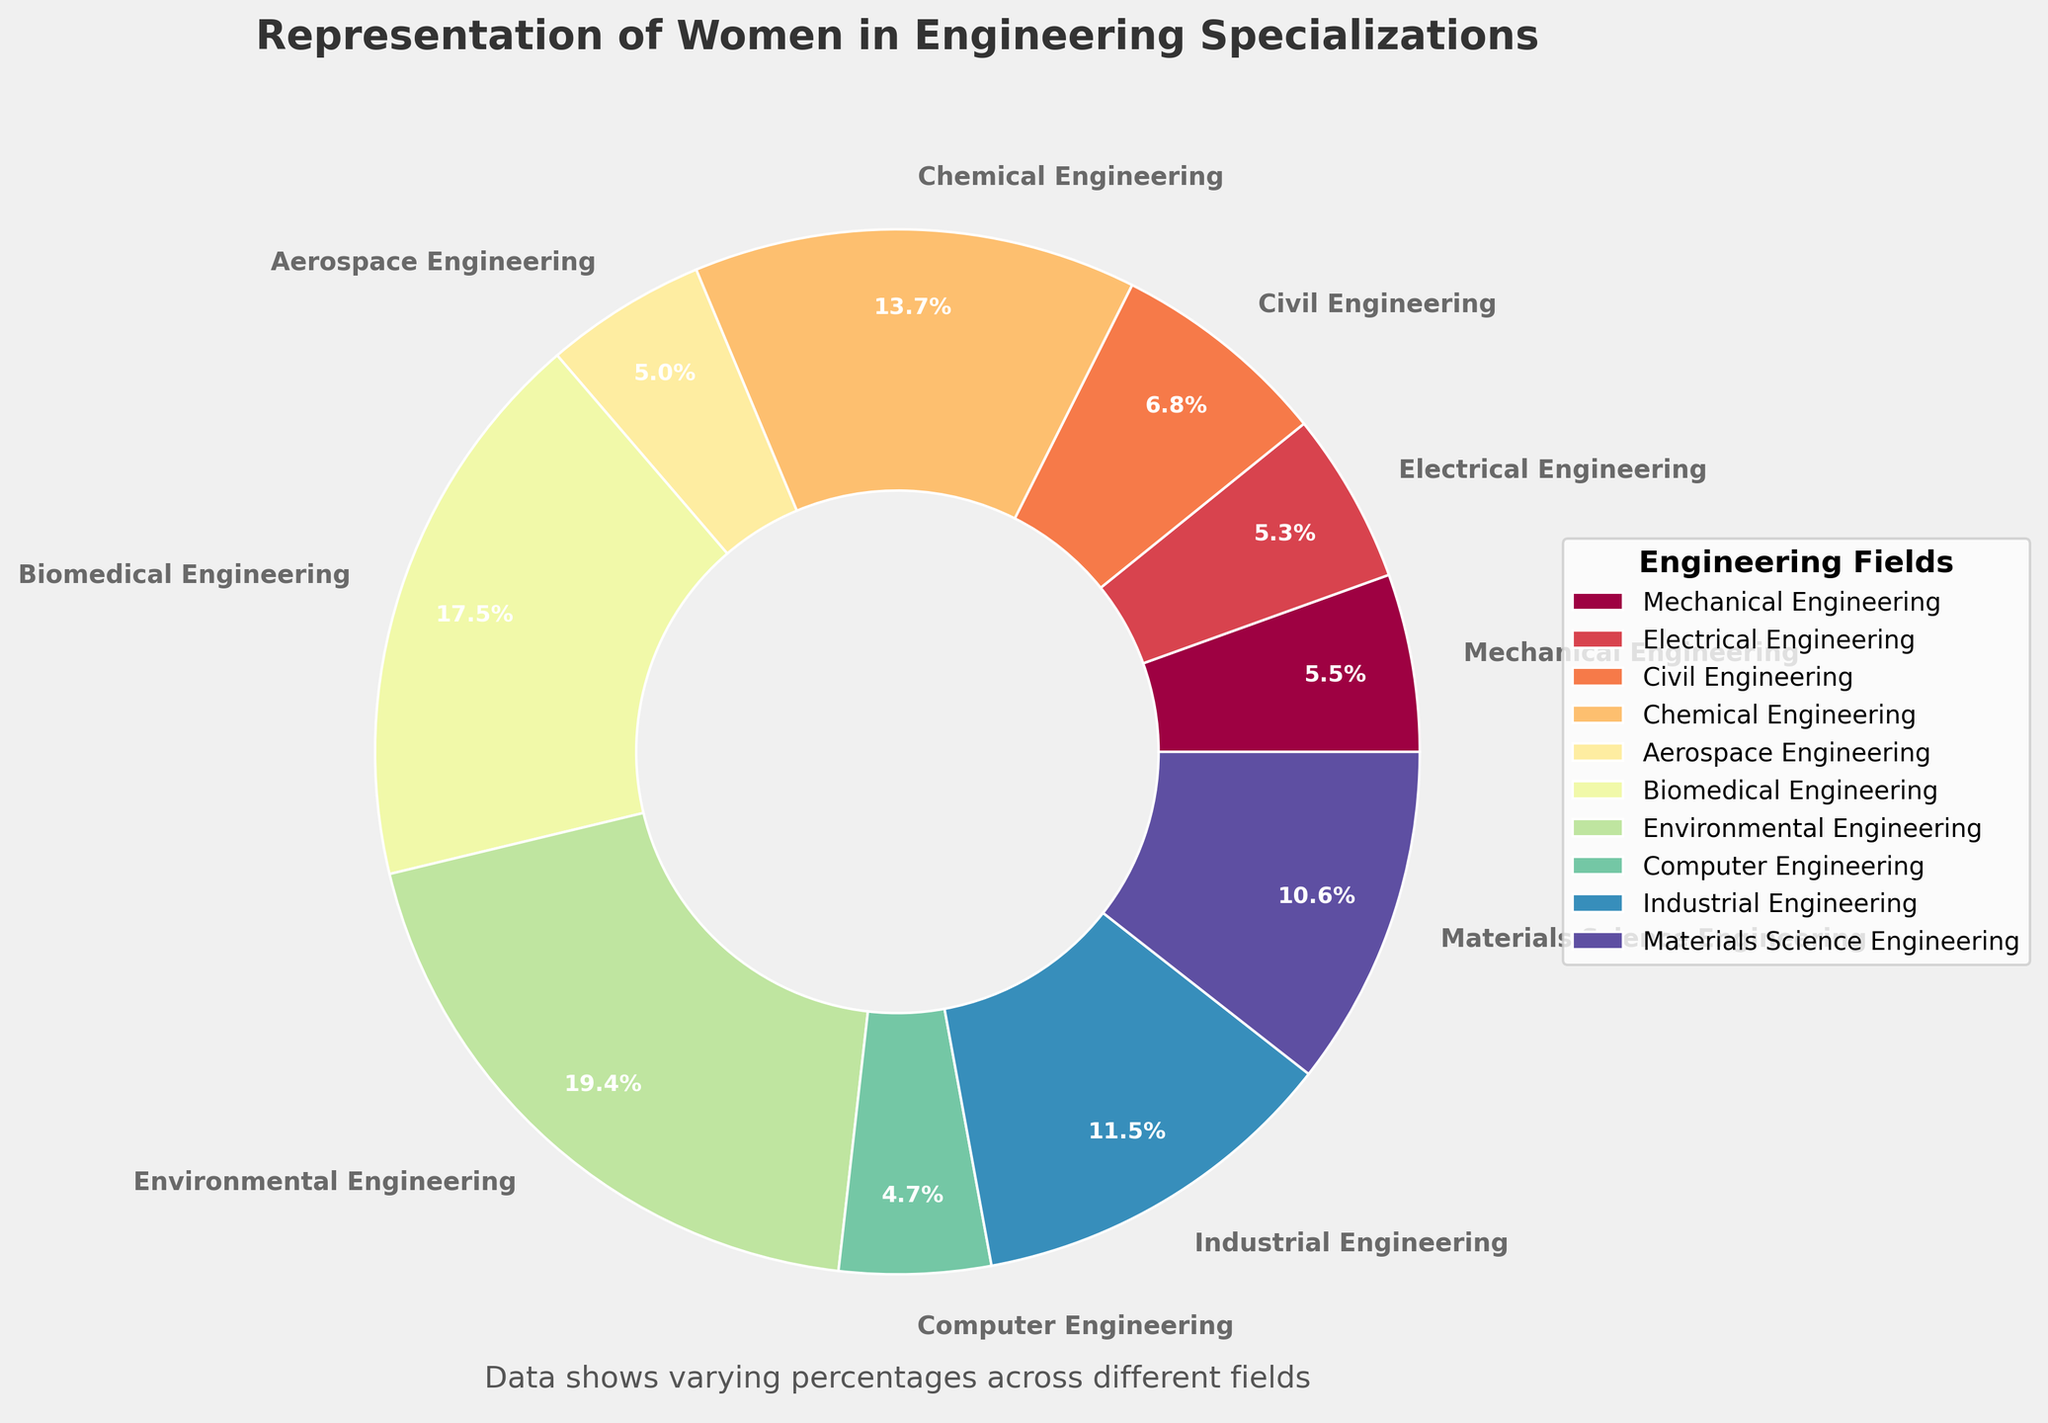What is the highest percentage of women in any engineering specialization? By looking at the pie chart, identify the segment with the largest percentage label.
Answer: 50.2% Which engineering specialization has the lowest representation of women? Find the smallest percentage value on the pie chart and note the specialization it corresponds to.
Answer: Computer Engineering (12.1%) What is the difference in the percentage of women between Chemical Engineering and Mechanical Engineering? Subtract the percentage of women in Mechanical Engineering (14.2%) from the percentage of women in Chemical Engineering (35.4%).
Answer: 21.2% Are there any engineering specializations with more than 40% representation of women? Check the pie chart for segments where the percentage is greater than 40%.
Answer: Yes, Biomedical Engineering (45.1%) and Environmental Engineering (50.2%) Among Electrical Engineering, Civil Engineering, and Aerospace Engineering, which has the greatest representation of women? Compare the percentages of women in Electrical (13.7%), Civil (17.5%), and Aerospace (12.9%) Engineering.
Answer: Civil Engineering How much higher is the percentage of women in Industrial Engineering compared to Computer Engineering? Subtract the percentage of women in Computer Engineering (12.1%) from the percentage of women in Industrial Engineering (29.8%).
Answer: 17.7% What is the average percentage of women in Mechanical, Electrical, and Aerospace Engineering? Add the percentages for Mechanical (14.2%), Electrical (13.7%), and Aerospace (12.9%) Engineering and divide by 3.
Answer: (14.2% + 13.7% + 12.9%) / 3 = 13.6% Which color represents Biomedical Engineering and what is the percentage of women in this specialization? Identify the segment labeled Biomedical Engineering and note its color and percentage.
Answer: The specific color might vary, but the percentage is 45.1% How does the representation of women in Materials Science Engineering compare to that in Civil Engineering? Compare the percentages of women in Materials Science Engineering (27.3%) and Civil Engineering (17.5%).
Answer: Materials Science Engineering has a higher representation (27.3% vs. 17.5%) What is the total representation of women in Mechanical, Electrical, and Civil Engineering specializations combined? Add the percentages of women in Mechanical (14.2%), Electrical (13.7%), and Civil (17.5%) Engineering.
Answer: 14.2% + 13.7% + 17.5% = 45.4% 